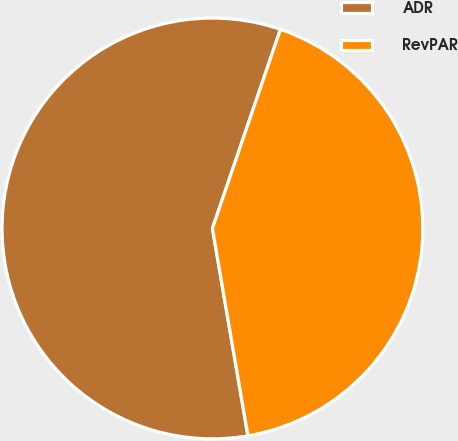Convert chart to OTSL. <chart><loc_0><loc_0><loc_500><loc_500><pie_chart><fcel>ADR<fcel>RevPAR<nl><fcel>57.94%<fcel>42.06%<nl></chart> 